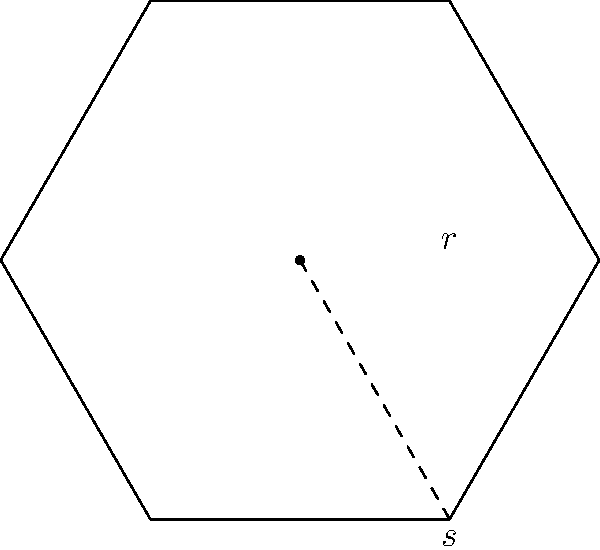You're designing a new hexagonal yoga mat for your holistic wellness class. If each side of the hexagon measures 3 feet, what is the total area of the yoga mat in square feet? (Use $\sqrt{3} \approx 1.732$ for calculations) To find the area of a regular hexagon, we can use the formula:

$$A = \frac{3\sqrt{3}}{2}s^2$$

Where $s$ is the length of one side.

Given:
- Side length ($s$) = 3 feet
- $\sqrt{3} \approx 1.732$

Steps:
1. Substitute the values into the formula:
   $$A = \frac{3\sqrt{3}}{2}(3^2)$$

2. Simplify inside the parentheses:
   $$A = \frac{3\sqrt{3}}{2}(9)$$

3. Multiply:
   $$A = \frac{27\sqrt{3}}{2}$$

4. Use the approximation for $\sqrt{3}$:
   $$A \approx \frac{27(1.732)}{2}$$

5. Multiply:
   $$A \approx \frac{46.764}{2}$$

6. Divide:
   $$A \approx 23.382$$

7. Round to two decimal places:
   $$A \approx 23.38\text{ sq ft}$$

Therefore, the total area of the hexagonal yoga mat is approximately 23.38 square feet.
Answer: 23.38 sq ft 